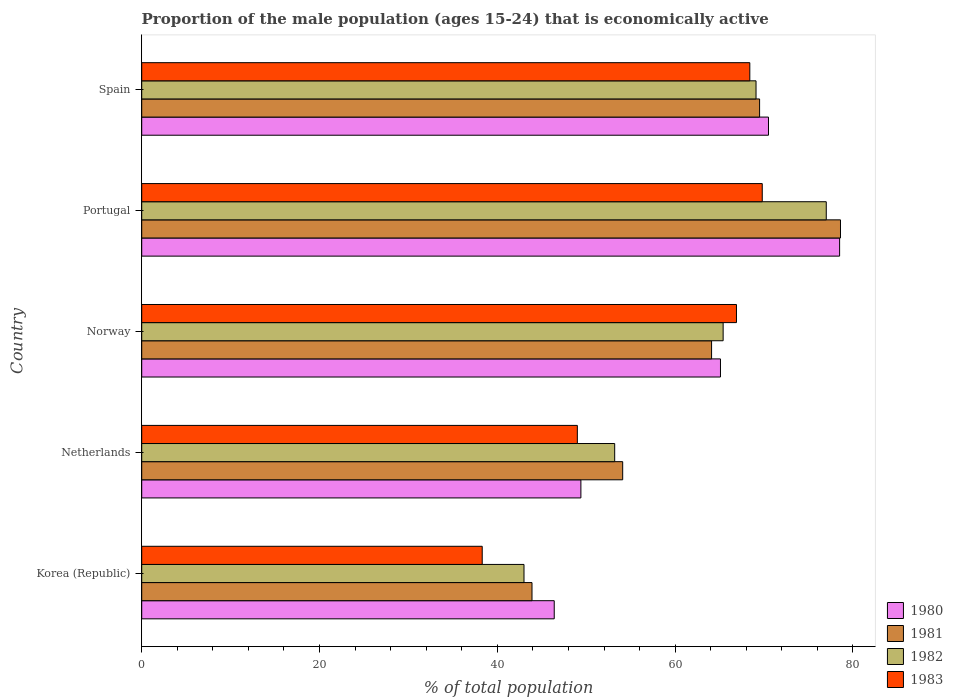Are the number of bars per tick equal to the number of legend labels?
Provide a short and direct response. Yes. What is the label of the 5th group of bars from the top?
Ensure brevity in your answer.  Korea (Republic). What is the proportion of the male population that is economically active in 1980 in Norway?
Offer a very short reply. 65.1. Across all countries, what is the maximum proportion of the male population that is economically active in 1983?
Offer a very short reply. 69.8. Across all countries, what is the minimum proportion of the male population that is economically active in 1982?
Your answer should be very brief. 43. In which country was the proportion of the male population that is economically active in 1982 maximum?
Your answer should be very brief. Portugal. What is the total proportion of the male population that is economically active in 1981 in the graph?
Ensure brevity in your answer.  310.2. What is the difference between the proportion of the male population that is economically active in 1982 in Netherlands and that in Portugal?
Keep it short and to the point. -23.8. What is the difference between the proportion of the male population that is economically active in 1983 in Portugal and the proportion of the male population that is economically active in 1982 in Norway?
Your response must be concise. 4.4. What is the average proportion of the male population that is economically active in 1982 per country?
Ensure brevity in your answer.  61.54. What is the difference between the proportion of the male population that is economically active in 1983 and proportion of the male population that is economically active in 1982 in Korea (Republic)?
Keep it short and to the point. -4.7. What is the ratio of the proportion of the male population that is economically active in 1980 in Netherlands to that in Norway?
Offer a very short reply. 0.76. Is the proportion of the male population that is economically active in 1983 in Korea (Republic) less than that in Portugal?
Make the answer very short. Yes. Is the difference between the proportion of the male population that is economically active in 1983 in Korea (Republic) and Norway greater than the difference between the proportion of the male population that is economically active in 1982 in Korea (Republic) and Norway?
Your answer should be very brief. No. What is the difference between the highest and the second highest proportion of the male population that is economically active in 1980?
Keep it short and to the point. 8. What is the difference between the highest and the lowest proportion of the male population that is economically active in 1983?
Give a very brief answer. 31.5. In how many countries, is the proportion of the male population that is economically active in 1983 greater than the average proportion of the male population that is economically active in 1983 taken over all countries?
Your response must be concise. 3. How many bars are there?
Offer a very short reply. 20. Are all the bars in the graph horizontal?
Ensure brevity in your answer.  Yes. How many legend labels are there?
Your response must be concise. 4. What is the title of the graph?
Provide a short and direct response. Proportion of the male population (ages 15-24) that is economically active. Does "2004" appear as one of the legend labels in the graph?
Ensure brevity in your answer.  No. What is the label or title of the X-axis?
Your answer should be very brief. % of total population. What is the label or title of the Y-axis?
Your answer should be very brief. Country. What is the % of total population in 1980 in Korea (Republic)?
Give a very brief answer. 46.4. What is the % of total population in 1981 in Korea (Republic)?
Make the answer very short. 43.9. What is the % of total population in 1983 in Korea (Republic)?
Provide a short and direct response. 38.3. What is the % of total population in 1980 in Netherlands?
Your answer should be compact. 49.4. What is the % of total population in 1981 in Netherlands?
Offer a very short reply. 54.1. What is the % of total population of 1982 in Netherlands?
Your answer should be very brief. 53.2. What is the % of total population of 1983 in Netherlands?
Your answer should be very brief. 49. What is the % of total population in 1980 in Norway?
Provide a short and direct response. 65.1. What is the % of total population in 1981 in Norway?
Your answer should be very brief. 64.1. What is the % of total population in 1982 in Norway?
Make the answer very short. 65.4. What is the % of total population of 1983 in Norway?
Offer a terse response. 66.9. What is the % of total population in 1980 in Portugal?
Make the answer very short. 78.5. What is the % of total population in 1981 in Portugal?
Offer a very short reply. 78.6. What is the % of total population in 1983 in Portugal?
Offer a terse response. 69.8. What is the % of total population of 1980 in Spain?
Offer a terse response. 70.5. What is the % of total population in 1981 in Spain?
Provide a short and direct response. 69.5. What is the % of total population in 1982 in Spain?
Ensure brevity in your answer.  69.1. What is the % of total population in 1983 in Spain?
Give a very brief answer. 68.4. Across all countries, what is the maximum % of total population of 1980?
Your answer should be very brief. 78.5. Across all countries, what is the maximum % of total population of 1981?
Provide a short and direct response. 78.6. Across all countries, what is the maximum % of total population of 1983?
Ensure brevity in your answer.  69.8. Across all countries, what is the minimum % of total population in 1980?
Give a very brief answer. 46.4. Across all countries, what is the minimum % of total population of 1981?
Offer a very short reply. 43.9. Across all countries, what is the minimum % of total population in 1983?
Offer a terse response. 38.3. What is the total % of total population of 1980 in the graph?
Make the answer very short. 309.9. What is the total % of total population of 1981 in the graph?
Offer a very short reply. 310.2. What is the total % of total population of 1982 in the graph?
Your answer should be compact. 307.7. What is the total % of total population of 1983 in the graph?
Give a very brief answer. 292.4. What is the difference between the % of total population in 1980 in Korea (Republic) and that in Netherlands?
Your answer should be compact. -3. What is the difference between the % of total population in 1981 in Korea (Republic) and that in Netherlands?
Provide a short and direct response. -10.2. What is the difference between the % of total population in 1980 in Korea (Republic) and that in Norway?
Offer a very short reply. -18.7. What is the difference between the % of total population of 1981 in Korea (Republic) and that in Norway?
Your answer should be very brief. -20.2. What is the difference between the % of total population of 1982 in Korea (Republic) and that in Norway?
Provide a succinct answer. -22.4. What is the difference between the % of total population in 1983 in Korea (Republic) and that in Norway?
Ensure brevity in your answer.  -28.6. What is the difference between the % of total population in 1980 in Korea (Republic) and that in Portugal?
Your answer should be very brief. -32.1. What is the difference between the % of total population of 1981 in Korea (Republic) and that in Portugal?
Give a very brief answer. -34.7. What is the difference between the % of total population of 1982 in Korea (Republic) and that in Portugal?
Your answer should be very brief. -34. What is the difference between the % of total population of 1983 in Korea (Republic) and that in Portugal?
Make the answer very short. -31.5. What is the difference between the % of total population in 1980 in Korea (Republic) and that in Spain?
Make the answer very short. -24.1. What is the difference between the % of total population of 1981 in Korea (Republic) and that in Spain?
Give a very brief answer. -25.6. What is the difference between the % of total population in 1982 in Korea (Republic) and that in Spain?
Your response must be concise. -26.1. What is the difference between the % of total population of 1983 in Korea (Republic) and that in Spain?
Provide a short and direct response. -30.1. What is the difference between the % of total population in 1980 in Netherlands and that in Norway?
Keep it short and to the point. -15.7. What is the difference between the % of total population in 1982 in Netherlands and that in Norway?
Offer a terse response. -12.2. What is the difference between the % of total population of 1983 in Netherlands and that in Norway?
Ensure brevity in your answer.  -17.9. What is the difference between the % of total population in 1980 in Netherlands and that in Portugal?
Provide a short and direct response. -29.1. What is the difference between the % of total population of 1981 in Netherlands and that in Portugal?
Make the answer very short. -24.5. What is the difference between the % of total population in 1982 in Netherlands and that in Portugal?
Provide a short and direct response. -23.8. What is the difference between the % of total population in 1983 in Netherlands and that in Portugal?
Your response must be concise. -20.8. What is the difference between the % of total population of 1980 in Netherlands and that in Spain?
Make the answer very short. -21.1. What is the difference between the % of total population in 1981 in Netherlands and that in Spain?
Offer a terse response. -15.4. What is the difference between the % of total population in 1982 in Netherlands and that in Spain?
Ensure brevity in your answer.  -15.9. What is the difference between the % of total population of 1983 in Netherlands and that in Spain?
Keep it short and to the point. -19.4. What is the difference between the % of total population in 1980 in Norway and that in Portugal?
Your answer should be compact. -13.4. What is the difference between the % of total population of 1981 in Norway and that in Portugal?
Offer a terse response. -14.5. What is the difference between the % of total population in 1982 in Norway and that in Portugal?
Provide a succinct answer. -11.6. What is the difference between the % of total population in 1983 in Norway and that in Portugal?
Provide a succinct answer. -2.9. What is the difference between the % of total population of 1980 in Norway and that in Spain?
Provide a succinct answer. -5.4. What is the difference between the % of total population in 1980 in Portugal and that in Spain?
Offer a terse response. 8. What is the difference between the % of total population of 1982 in Portugal and that in Spain?
Provide a succinct answer. 7.9. What is the difference between the % of total population of 1983 in Portugal and that in Spain?
Your answer should be compact. 1.4. What is the difference between the % of total population in 1980 in Korea (Republic) and the % of total population in 1981 in Netherlands?
Give a very brief answer. -7.7. What is the difference between the % of total population in 1981 in Korea (Republic) and the % of total population in 1982 in Netherlands?
Your answer should be compact. -9.3. What is the difference between the % of total population in 1981 in Korea (Republic) and the % of total population in 1983 in Netherlands?
Your answer should be very brief. -5.1. What is the difference between the % of total population in 1980 in Korea (Republic) and the % of total population in 1981 in Norway?
Ensure brevity in your answer.  -17.7. What is the difference between the % of total population of 1980 in Korea (Republic) and the % of total population of 1983 in Norway?
Provide a succinct answer. -20.5. What is the difference between the % of total population in 1981 in Korea (Republic) and the % of total population in 1982 in Norway?
Provide a succinct answer. -21.5. What is the difference between the % of total population of 1981 in Korea (Republic) and the % of total population of 1983 in Norway?
Your answer should be compact. -23. What is the difference between the % of total population of 1982 in Korea (Republic) and the % of total population of 1983 in Norway?
Keep it short and to the point. -23.9. What is the difference between the % of total population in 1980 in Korea (Republic) and the % of total population in 1981 in Portugal?
Provide a succinct answer. -32.2. What is the difference between the % of total population in 1980 in Korea (Republic) and the % of total population in 1982 in Portugal?
Provide a succinct answer. -30.6. What is the difference between the % of total population in 1980 in Korea (Republic) and the % of total population in 1983 in Portugal?
Your answer should be compact. -23.4. What is the difference between the % of total population in 1981 in Korea (Republic) and the % of total population in 1982 in Portugal?
Keep it short and to the point. -33.1. What is the difference between the % of total population in 1981 in Korea (Republic) and the % of total population in 1983 in Portugal?
Keep it short and to the point. -25.9. What is the difference between the % of total population of 1982 in Korea (Republic) and the % of total population of 1983 in Portugal?
Your response must be concise. -26.8. What is the difference between the % of total population of 1980 in Korea (Republic) and the % of total population of 1981 in Spain?
Your answer should be very brief. -23.1. What is the difference between the % of total population of 1980 in Korea (Republic) and the % of total population of 1982 in Spain?
Give a very brief answer. -22.7. What is the difference between the % of total population of 1981 in Korea (Republic) and the % of total population of 1982 in Spain?
Keep it short and to the point. -25.2. What is the difference between the % of total population in 1981 in Korea (Republic) and the % of total population in 1983 in Spain?
Keep it short and to the point. -24.5. What is the difference between the % of total population in 1982 in Korea (Republic) and the % of total population in 1983 in Spain?
Offer a terse response. -25.4. What is the difference between the % of total population of 1980 in Netherlands and the % of total population of 1981 in Norway?
Give a very brief answer. -14.7. What is the difference between the % of total population of 1980 in Netherlands and the % of total population of 1983 in Norway?
Offer a terse response. -17.5. What is the difference between the % of total population in 1981 in Netherlands and the % of total population in 1982 in Norway?
Your answer should be compact. -11.3. What is the difference between the % of total population of 1981 in Netherlands and the % of total population of 1983 in Norway?
Offer a very short reply. -12.8. What is the difference between the % of total population of 1982 in Netherlands and the % of total population of 1983 in Norway?
Give a very brief answer. -13.7. What is the difference between the % of total population in 1980 in Netherlands and the % of total population in 1981 in Portugal?
Make the answer very short. -29.2. What is the difference between the % of total population of 1980 in Netherlands and the % of total population of 1982 in Portugal?
Ensure brevity in your answer.  -27.6. What is the difference between the % of total population of 1980 in Netherlands and the % of total population of 1983 in Portugal?
Keep it short and to the point. -20.4. What is the difference between the % of total population of 1981 in Netherlands and the % of total population of 1982 in Portugal?
Your answer should be compact. -22.9. What is the difference between the % of total population in 1981 in Netherlands and the % of total population in 1983 in Portugal?
Offer a very short reply. -15.7. What is the difference between the % of total population of 1982 in Netherlands and the % of total population of 1983 in Portugal?
Your response must be concise. -16.6. What is the difference between the % of total population in 1980 in Netherlands and the % of total population in 1981 in Spain?
Ensure brevity in your answer.  -20.1. What is the difference between the % of total population in 1980 in Netherlands and the % of total population in 1982 in Spain?
Ensure brevity in your answer.  -19.7. What is the difference between the % of total population of 1980 in Netherlands and the % of total population of 1983 in Spain?
Offer a terse response. -19. What is the difference between the % of total population in 1981 in Netherlands and the % of total population in 1983 in Spain?
Ensure brevity in your answer.  -14.3. What is the difference between the % of total population in 1982 in Netherlands and the % of total population in 1983 in Spain?
Ensure brevity in your answer.  -15.2. What is the difference between the % of total population in 1980 in Norway and the % of total population in 1981 in Portugal?
Your response must be concise. -13.5. What is the difference between the % of total population of 1980 in Norway and the % of total population of 1982 in Portugal?
Offer a very short reply. -11.9. What is the difference between the % of total population of 1980 in Norway and the % of total population of 1983 in Portugal?
Give a very brief answer. -4.7. What is the difference between the % of total population in 1981 in Norway and the % of total population in 1982 in Portugal?
Your answer should be compact. -12.9. What is the difference between the % of total population of 1981 in Norway and the % of total population of 1983 in Portugal?
Provide a short and direct response. -5.7. What is the difference between the % of total population of 1980 in Norway and the % of total population of 1981 in Spain?
Offer a very short reply. -4.4. What is the difference between the % of total population in 1980 in Norway and the % of total population in 1982 in Spain?
Your answer should be very brief. -4. What is the difference between the % of total population of 1981 in Norway and the % of total population of 1982 in Spain?
Your answer should be very brief. -5. What is the difference between the % of total population of 1981 in Norway and the % of total population of 1983 in Spain?
Offer a very short reply. -4.3. What is the difference between the % of total population in 1980 in Portugal and the % of total population in 1983 in Spain?
Your answer should be very brief. 10.1. What is the difference between the % of total population of 1982 in Portugal and the % of total population of 1983 in Spain?
Make the answer very short. 8.6. What is the average % of total population in 1980 per country?
Your answer should be compact. 61.98. What is the average % of total population in 1981 per country?
Your answer should be very brief. 62.04. What is the average % of total population of 1982 per country?
Offer a very short reply. 61.54. What is the average % of total population of 1983 per country?
Your answer should be compact. 58.48. What is the difference between the % of total population of 1980 and % of total population of 1981 in Korea (Republic)?
Your response must be concise. 2.5. What is the difference between the % of total population of 1980 and % of total population of 1982 in Korea (Republic)?
Your answer should be compact. 3.4. What is the difference between the % of total population of 1980 and % of total population of 1981 in Netherlands?
Ensure brevity in your answer.  -4.7. What is the difference between the % of total population of 1980 and % of total population of 1982 in Netherlands?
Keep it short and to the point. -3.8. What is the difference between the % of total population in 1980 and % of total population in 1983 in Netherlands?
Make the answer very short. 0.4. What is the difference between the % of total population of 1981 and % of total population of 1982 in Netherlands?
Give a very brief answer. 0.9. What is the difference between the % of total population of 1980 and % of total population of 1981 in Norway?
Your answer should be compact. 1. What is the difference between the % of total population in 1980 and % of total population in 1982 in Norway?
Ensure brevity in your answer.  -0.3. What is the difference between the % of total population of 1980 and % of total population of 1983 in Norway?
Provide a short and direct response. -1.8. What is the difference between the % of total population of 1981 and % of total population of 1982 in Norway?
Your answer should be compact. -1.3. What is the difference between the % of total population in 1981 and % of total population in 1983 in Norway?
Your response must be concise. -2.8. What is the difference between the % of total population in 1980 and % of total population in 1981 in Portugal?
Make the answer very short. -0.1. What is the difference between the % of total population of 1980 and % of total population of 1983 in Portugal?
Ensure brevity in your answer.  8.7. What is the difference between the % of total population of 1981 and % of total population of 1982 in Portugal?
Give a very brief answer. 1.6. What is the difference between the % of total population in 1981 and % of total population in 1983 in Portugal?
Give a very brief answer. 8.8. What is the difference between the % of total population in 1980 and % of total population in 1982 in Spain?
Offer a terse response. 1.4. What is the difference between the % of total population in 1981 and % of total population in 1983 in Spain?
Provide a short and direct response. 1.1. What is the difference between the % of total population of 1982 and % of total population of 1983 in Spain?
Offer a terse response. 0.7. What is the ratio of the % of total population of 1980 in Korea (Republic) to that in Netherlands?
Your response must be concise. 0.94. What is the ratio of the % of total population of 1981 in Korea (Republic) to that in Netherlands?
Give a very brief answer. 0.81. What is the ratio of the % of total population in 1982 in Korea (Republic) to that in Netherlands?
Provide a succinct answer. 0.81. What is the ratio of the % of total population of 1983 in Korea (Republic) to that in Netherlands?
Provide a short and direct response. 0.78. What is the ratio of the % of total population of 1980 in Korea (Republic) to that in Norway?
Provide a short and direct response. 0.71. What is the ratio of the % of total population in 1981 in Korea (Republic) to that in Norway?
Your answer should be compact. 0.68. What is the ratio of the % of total population of 1982 in Korea (Republic) to that in Norway?
Keep it short and to the point. 0.66. What is the ratio of the % of total population in 1983 in Korea (Republic) to that in Norway?
Keep it short and to the point. 0.57. What is the ratio of the % of total population of 1980 in Korea (Republic) to that in Portugal?
Make the answer very short. 0.59. What is the ratio of the % of total population in 1981 in Korea (Republic) to that in Portugal?
Your answer should be compact. 0.56. What is the ratio of the % of total population in 1982 in Korea (Republic) to that in Portugal?
Your response must be concise. 0.56. What is the ratio of the % of total population of 1983 in Korea (Republic) to that in Portugal?
Offer a terse response. 0.55. What is the ratio of the % of total population in 1980 in Korea (Republic) to that in Spain?
Your response must be concise. 0.66. What is the ratio of the % of total population of 1981 in Korea (Republic) to that in Spain?
Offer a very short reply. 0.63. What is the ratio of the % of total population of 1982 in Korea (Republic) to that in Spain?
Provide a succinct answer. 0.62. What is the ratio of the % of total population of 1983 in Korea (Republic) to that in Spain?
Provide a short and direct response. 0.56. What is the ratio of the % of total population of 1980 in Netherlands to that in Norway?
Ensure brevity in your answer.  0.76. What is the ratio of the % of total population of 1981 in Netherlands to that in Norway?
Make the answer very short. 0.84. What is the ratio of the % of total population of 1982 in Netherlands to that in Norway?
Make the answer very short. 0.81. What is the ratio of the % of total population in 1983 in Netherlands to that in Norway?
Ensure brevity in your answer.  0.73. What is the ratio of the % of total population in 1980 in Netherlands to that in Portugal?
Make the answer very short. 0.63. What is the ratio of the % of total population in 1981 in Netherlands to that in Portugal?
Provide a short and direct response. 0.69. What is the ratio of the % of total population of 1982 in Netherlands to that in Portugal?
Your answer should be compact. 0.69. What is the ratio of the % of total population in 1983 in Netherlands to that in Portugal?
Your response must be concise. 0.7. What is the ratio of the % of total population of 1980 in Netherlands to that in Spain?
Keep it short and to the point. 0.7. What is the ratio of the % of total population in 1981 in Netherlands to that in Spain?
Offer a terse response. 0.78. What is the ratio of the % of total population in 1982 in Netherlands to that in Spain?
Your answer should be compact. 0.77. What is the ratio of the % of total population in 1983 in Netherlands to that in Spain?
Keep it short and to the point. 0.72. What is the ratio of the % of total population in 1980 in Norway to that in Portugal?
Your response must be concise. 0.83. What is the ratio of the % of total population of 1981 in Norway to that in Portugal?
Keep it short and to the point. 0.82. What is the ratio of the % of total population in 1982 in Norway to that in Portugal?
Offer a very short reply. 0.85. What is the ratio of the % of total population in 1983 in Norway to that in Portugal?
Provide a short and direct response. 0.96. What is the ratio of the % of total population of 1980 in Norway to that in Spain?
Provide a short and direct response. 0.92. What is the ratio of the % of total population of 1981 in Norway to that in Spain?
Your answer should be compact. 0.92. What is the ratio of the % of total population in 1982 in Norway to that in Spain?
Provide a short and direct response. 0.95. What is the ratio of the % of total population in 1983 in Norway to that in Spain?
Offer a very short reply. 0.98. What is the ratio of the % of total population in 1980 in Portugal to that in Spain?
Ensure brevity in your answer.  1.11. What is the ratio of the % of total population of 1981 in Portugal to that in Spain?
Ensure brevity in your answer.  1.13. What is the ratio of the % of total population of 1982 in Portugal to that in Spain?
Offer a very short reply. 1.11. What is the ratio of the % of total population of 1983 in Portugal to that in Spain?
Keep it short and to the point. 1.02. What is the difference between the highest and the second highest % of total population of 1981?
Your answer should be very brief. 9.1. What is the difference between the highest and the second highest % of total population in 1982?
Give a very brief answer. 7.9. What is the difference between the highest and the second highest % of total population of 1983?
Offer a very short reply. 1.4. What is the difference between the highest and the lowest % of total population in 1980?
Provide a short and direct response. 32.1. What is the difference between the highest and the lowest % of total population in 1981?
Offer a terse response. 34.7. What is the difference between the highest and the lowest % of total population of 1983?
Your response must be concise. 31.5. 